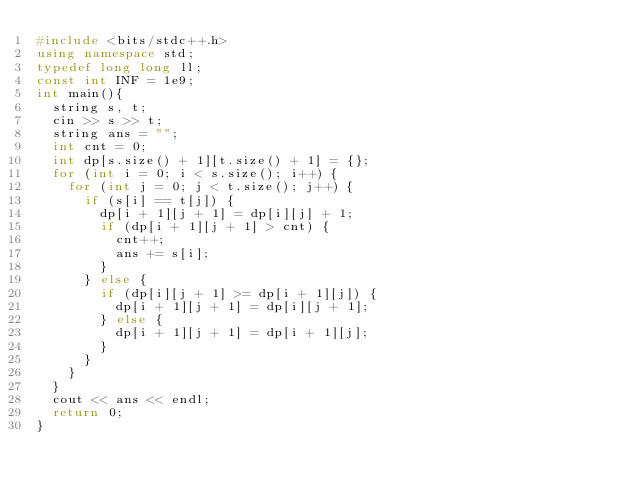Convert code to text. <code><loc_0><loc_0><loc_500><loc_500><_C++_>#include <bits/stdc++.h>
using namespace std;
typedef long long ll;
const int INF = 1e9;
int main(){
  string s, t;
  cin >> s >> t;
  string ans = "";
  int cnt = 0;
  int dp[s.size() + 1][t.size() + 1] = {};
  for (int i = 0; i < s.size(); i++) {
    for (int j = 0; j < t.size(); j++) {
      if (s[i] == t[j]) {
        dp[i + 1][j + 1] = dp[i][j] + 1;
        if (dp[i + 1][j + 1] > cnt) {
          cnt++;
          ans += s[i];
        }
      } else {
        if (dp[i][j + 1] >= dp[i + 1][j]) {
          dp[i + 1][j + 1] = dp[i][j + 1];
        } else {
          dp[i + 1][j + 1] = dp[i + 1][j];
        }
      }
    }
  }
  cout << ans << endl;
  return 0;
}
</code> 